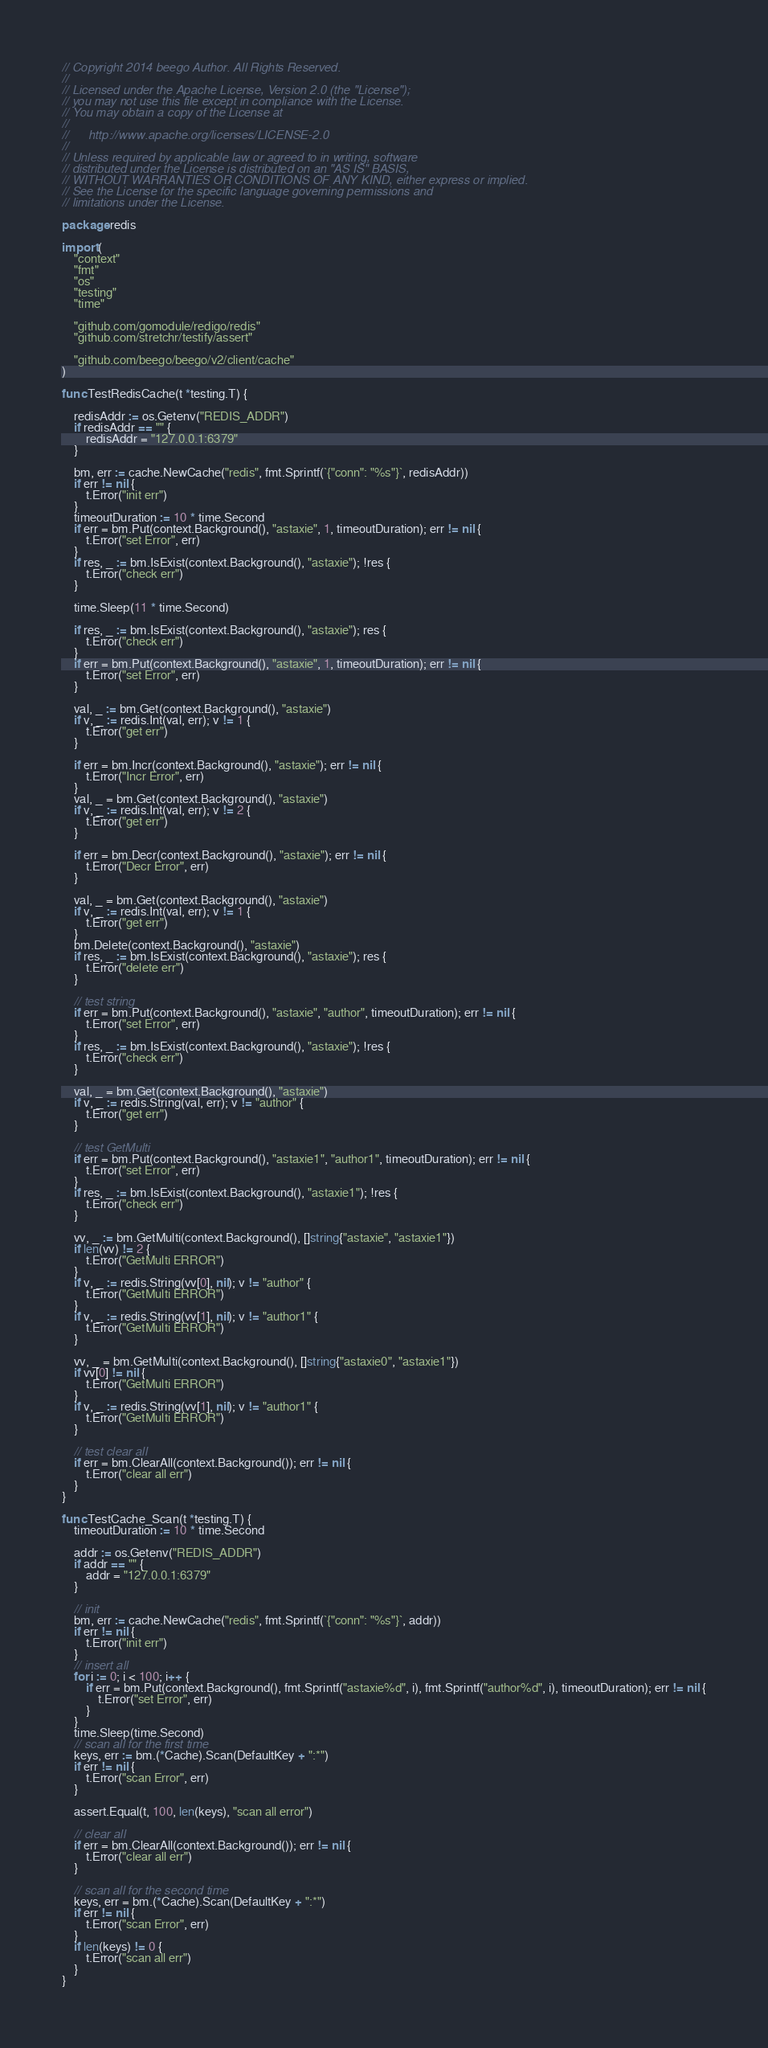<code> <loc_0><loc_0><loc_500><loc_500><_Go_>// Copyright 2014 beego Author. All Rights Reserved.
//
// Licensed under the Apache License, Version 2.0 (the "License");
// you may not use this file except in compliance with the License.
// You may obtain a copy of the License at
//
//      http://www.apache.org/licenses/LICENSE-2.0
//
// Unless required by applicable law or agreed to in writing, software
// distributed under the License is distributed on an "AS IS" BASIS,
// WITHOUT WARRANTIES OR CONDITIONS OF ANY KIND, either express or implied.
// See the License for the specific language governing permissions and
// limitations under the License.

package redis

import (
	"context"
	"fmt"
	"os"
	"testing"
	"time"

	"github.com/gomodule/redigo/redis"
	"github.com/stretchr/testify/assert"

	"github.com/beego/beego/v2/client/cache"
)

func TestRedisCache(t *testing.T) {

	redisAddr := os.Getenv("REDIS_ADDR")
	if redisAddr == "" {
		redisAddr = "127.0.0.1:6379"
	}

	bm, err := cache.NewCache("redis", fmt.Sprintf(`{"conn": "%s"}`, redisAddr))
	if err != nil {
		t.Error("init err")
	}
	timeoutDuration := 10 * time.Second
	if err = bm.Put(context.Background(), "astaxie", 1, timeoutDuration); err != nil {
		t.Error("set Error", err)
	}
	if res, _ := bm.IsExist(context.Background(), "astaxie"); !res {
		t.Error("check err")
	}

	time.Sleep(11 * time.Second)

	if res, _ := bm.IsExist(context.Background(), "astaxie"); res {
		t.Error("check err")
	}
	if err = bm.Put(context.Background(), "astaxie", 1, timeoutDuration); err != nil {
		t.Error("set Error", err)
	}

	val, _ := bm.Get(context.Background(), "astaxie")
	if v, _ := redis.Int(val, err); v != 1 {
		t.Error("get err")
	}

	if err = bm.Incr(context.Background(), "astaxie"); err != nil {
		t.Error("Incr Error", err)
	}
	val, _ = bm.Get(context.Background(), "astaxie")
	if v, _ := redis.Int(val, err); v != 2 {
		t.Error("get err")
	}

	if err = bm.Decr(context.Background(), "astaxie"); err != nil {
		t.Error("Decr Error", err)
	}

	val, _ = bm.Get(context.Background(), "astaxie")
	if v, _ := redis.Int(val, err); v != 1 {
		t.Error("get err")
	}
	bm.Delete(context.Background(), "astaxie")
	if res, _ := bm.IsExist(context.Background(), "astaxie"); res {
		t.Error("delete err")
	}

	// test string
	if err = bm.Put(context.Background(), "astaxie", "author", timeoutDuration); err != nil {
		t.Error("set Error", err)
	}
	if res, _ := bm.IsExist(context.Background(), "astaxie"); !res {
		t.Error("check err")
	}

	val, _ = bm.Get(context.Background(), "astaxie")
	if v, _ := redis.String(val, err); v != "author" {
		t.Error("get err")
	}

	// test GetMulti
	if err = bm.Put(context.Background(), "astaxie1", "author1", timeoutDuration); err != nil {
		t.Error("set Error", err)
	}
	if res, _ := bm.IsExist(context.Background(), "astaxie1"); !res {
		t.Error("check err")
	}

	vv, _ := bm.GetMulti(context.Background(), []string{"astaxie", "astaxie1"})
	if len(vv) != 2 {
		t.Error("GetMulti ERROR")
	}
	if v, _ := redis.String(vv[0], nil); v != "author" {
		t.Error("GetMulti ERROR")
	}
	if v, _ := redis.String(vv[1], nil); v != "author1" {
		t.Error("GetMulti ERROR")
	}

	vv, _ = bm.GetMulti(context.Background(), []string{"astaxie0", "astaxie1"})
	if vv[0] != nil {
		t.Error("GetMulti ERROR")
	}
	if v, _ := redis.String(vv[1], nil); v != "author1" {
		t.Error("GetMulti ERROR")
	}

	// test clear all
	if err = bm.ClearAll(context.Background()); err != nil {
		t.Error("clear all err")
	}
}

func TestCache_Scan(t *testing.T) {
	timeoutDuration := 10 * time.Second

	addr := os.Getenv("REDIS_ADDR")
	if addr == "" {
		addr = "127.0.0.1:6379"
	}

	// init
	bm, err := cache.NewCache("redis", fmt.Sprintf(`{"conn": "%s"}`, addr))
	if err != nil {
		t.Error("init err")
	}
	// insert all
	for i := 0; i < 100; i++ {
		if err = bm.Put(context.Background(), fmt.Sprintf("astaxie%d", i), fmt.Sprintf("author%d", i), timeoutDuration); err != nil {
			t.Error("set Error", err)
		}
	}
	time.Sleep(time.Second)
	// scan all for the first time
	keys, err := bm.(*Cache).Scan(DefaultKey + ":*")
	if err != nil {
		t.Error("scan Error", err)
	}

	assert.Equal(t, 100, len(keys), "scan all error")

	// clear all
	if err = bm.ClearAll(context.Background()); err != nil {
		t.Error("clear all err")
	}

	// scan all for the second time
	keys, err = bm.(*Cache).Scan(DefaultKey + ":*")
	if err != nil {
		t.Error("scan Error", err)
	}
	if len(keys) != 0 {
		t.Error("scan all err")
	}
}
</code> 